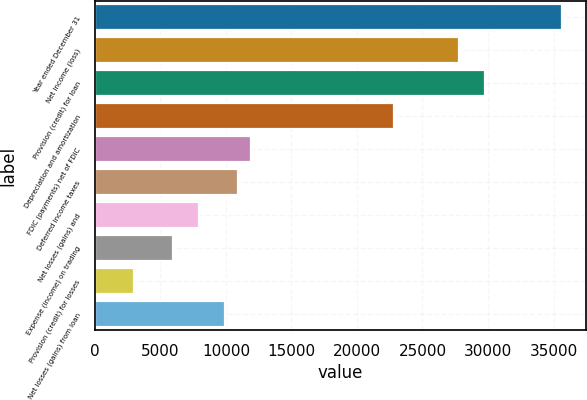Convert chart to OTSL. <chart><loc_0><loc_0><loc_500><loc_500><bar_chart><fcel>Year ended December 31<fcel>Net income (loss)<fcel>Provision (credit) for loan<fcel>Depreciation and amortization<fcel>FDIC (payments) net of FDIC<fcel>Deferred income taxes<fcel>Net losses (gains) and<fcel>Expense (income) on trading<fcel>Provision (credit) for losses<fcel>Net losses (gains) from loan<nl><fcel>35685.2<fcel>27755.6<fcel>29738<fcel>22799.6<fcel>11896.4<fcel>10905.2<fcel>7931.6<fcel>5949.2<fcel>2975.6<fcel>9914<nl></chart> 